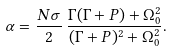Convert formula to latex. <formula><loc_0><loc_0><loc_500><loc_500>\alpha = \frac { N \sigma } { 2 } \, \frac { \Gamma ( \Gamma + P ) + \Omega _ { 0 } ^ { 2 } } { ( \Gamma + P ) ^ { 2 } + \Omega _ { 0 } ^ { 2 } } .</formula> 